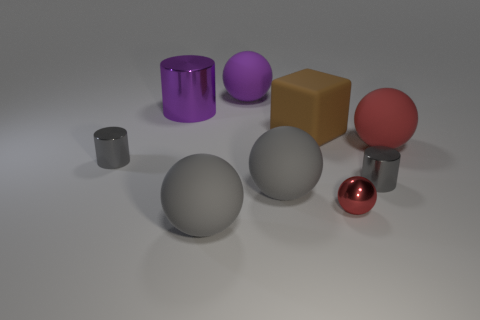There is a brown thing that is the same size as the purple ball; what is it made of?
Provide a succinct answer. Rubber. There is a metal thing on the left side of the purple cylinder; is its size the same as the big cube?
Your answer should be very brief. No. Do the gray matte object left of the big purple rubber ball and the big metal thing have the same shape?
Offer a terse response. No. How many things are either small spheres or small gray metal objects right of the large brown block?
Ensure brevity in your answer.  2. Are there fewer gray shiny cylinders than rubber things?
Keep it short and to the point. Yes. Are there more big balls than large brown blocks?
Your response must be concise. Yes. How many other things are there of the same material as the small red object?
Ensure brevity in your answer.  3. There is a rubber ball behind the matte ball that is on the right side of the small metal ball; what number of big balls are on the right side of it?
Your answer should be compact. 2. What number of rubber objects are blue spheres or big cylinders?
Offer a very short reply. 0. There is a red thing that is in front of the gray shiny object on the right side of the big cube; what is its size?
Provide a succinct answer. Small. 